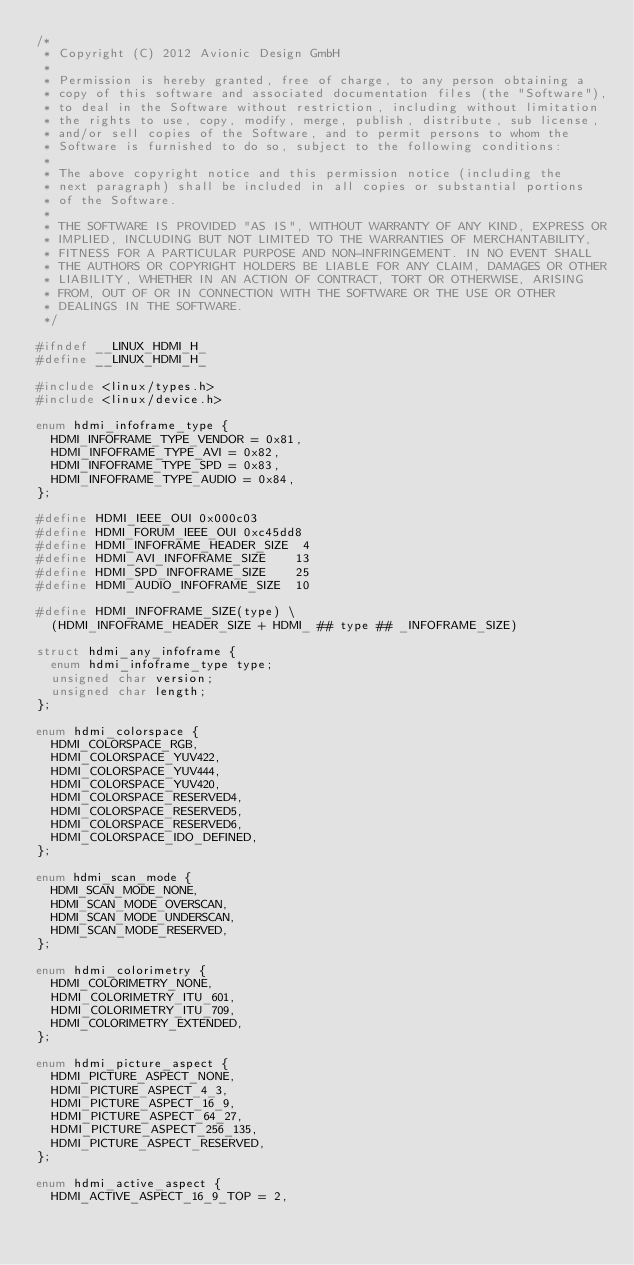Convert code to text. <code><loc_0><loc_0><loc_500><loc_500><_C_>/*
 * Copyright (C) 2012 Avionic Design GmbH
 *
 * Permission is hereby granted, free of charge, to any person obtaining a
 * copy of this software and associated documentation files (the "Software"),
 * to deal in the Software without restriction, including without limitation
 * the rights to use, copy, modify, merge, publish, distribute, sub license,
 * and/or sell copies of the Software, and to permit persons to whom the
 * Software is furnished to do so, subject to the following conditions:
 *
 * The above copyright notice and this permission notice (including the
 * next paragraph) shall be included in all copies or substantial portions
 * of the Software.
 *
 * THE SOFTWARE IS PROVIDED "AS IS", WITHOUT WARRANTY OF ANY KIND, EXPRESS OR
 * IMPLIED, INCLUDING BUT NOT LIMITED TO THE WARRANTIES OF MERCHANTABILITY,
 * FITNESS FOR A PARTICULAR PURPOSE AND NON-INFRINGEMENT. IN NO EVENT SHALL
 * THE AUTHORS OR COPYRIGHT HOLDERS BE LIABLE FOR ANY CLAIM, DAMAGES OR OTHER
 * LIABILITY, WHETHER IN AN ACTION OF CONTRACT, TORT OR OTHERWISE, ARISING
 * FROM, OUT OF OR IN CONNECTION WITH THE SOFTWARE OR THE USE OR OTHER
 * DEALINGS IN THE SOFTWARE.
 */

#ifndef __LINUX_HDMI_H_
#define __LINUX_HDMI_H_

#include <linux/types.h>
#include <linux/device.h>

enum hdmi_infoframe_type {
	HDMI_INFOFRAME_TYPE_VENDOR = 0x81,
	HDMI_INFOFRAME_TYPE_AVI = 0x82,
	HDMI_INFOFRAME_TYPE_SPD = 0x83,
	HDMI_INFOFRAME_TYPE_AUDIO = 0x84,
};

#define HDMI_IEEE_OUI 0x000c03
#define HDMI_FORUM_IEEE_OUI 0xc45dd8
#define HDMI_INFOFRAME_HEADER_SIZE  4
#define HDMI_AVI_INFOFRAME_SIZE    13
#define HDMI_SPD_INFOFRAME_SIZE    25
#define HDMI_AUDIO_INFOFRAME_SIZE  10

#define HDMI_INFOFRAME_SIZE(type)	\
	(HDMI_INFOFRAME_HEADER_SIZE + HDMI_ ## type ## _INFOFRAME_SIZE)

struct hdmi_any_infoframe {
	enum hdmi_infoframe_type type;
	unsigned char version;
	unsigned char length;
};

enum hdmi_colorspace {
	HDMI_COLORSPACE_RGB,
	HDMI_COLORSPACE_YUV422,
	HDMI_COLORSPACE_YUV444,
	HDMI_COLORSPACE_YUV420,
	HDMI_COLORSPACE_RESERVED4,
	HDMI_COLORSPACE_RESERVED5,
	HDMI_COLORSPACE_RESERVED6,
	HDMI_COLORSPACE_IDO_DEFINED,
};

enum hdmi_scan_mode {
	HDMI_SCAN_MODE_NONE,
	HDMI_SCAN_MODE_OVERSCAN,
	HDMI_SCAN_MODE_UNDERSCAN,
	HDMI_SCAN_MODE_RESERVED,
};

enum hdmi_colorimetry {
	HDMI_COLORIMETRY_NONE,
	HDMI_COLORIMETRY_ITU_601,
	HDMI_COLORIMETRY_ITU_709,
	HDMI_COLORIMETRY_EXTENDED,
};

enum hdmi_picture_aspect {
	HDMI_PICTURE_ASPECT_NONE,
	HDMI_PICTURE_ASPECT_4_3,
	HDMI_PICTURE_ASPECT_16_9,
	HDMI_PICTURE_ASPECT_64_27,
	HDMI_PICTURE_ASPECT_256_135,
	HDMI_PICTURE_ASPECT_RESERVED,
};

enum hdmi_active_aspect {
	HDMI_ACTIVE_ASPECT_16_9_TOP = 2,</code> 